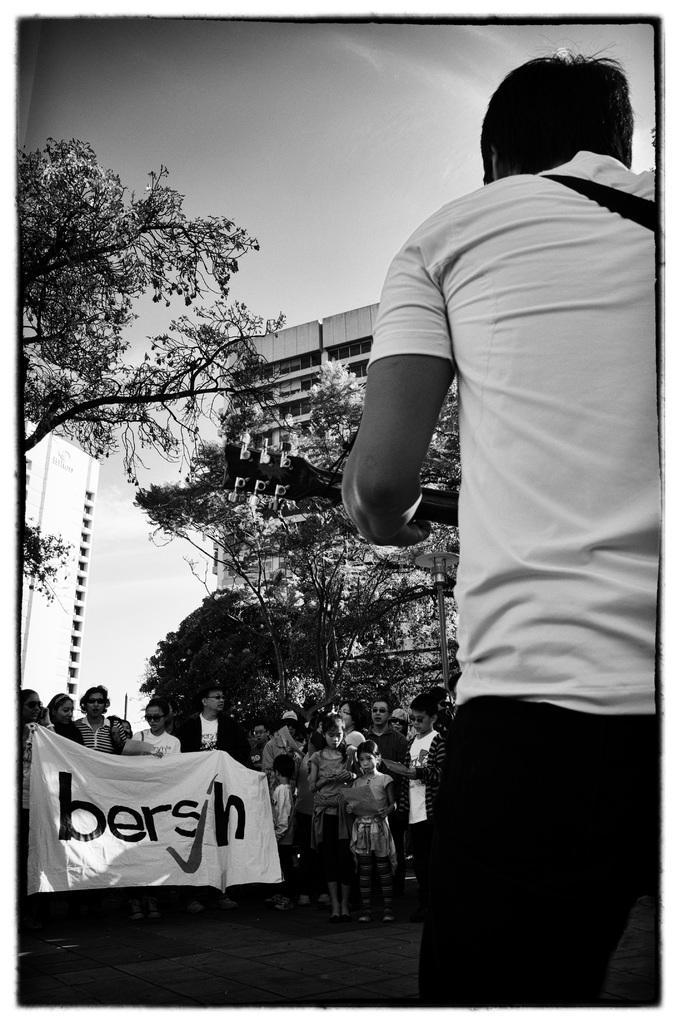Describe this image in one or two sentences. In this picture there is a boy on the right side of the image and there are people at the bottom side of the image, by holding flex in their hands and there are buildings and trees in the background area of the image. 